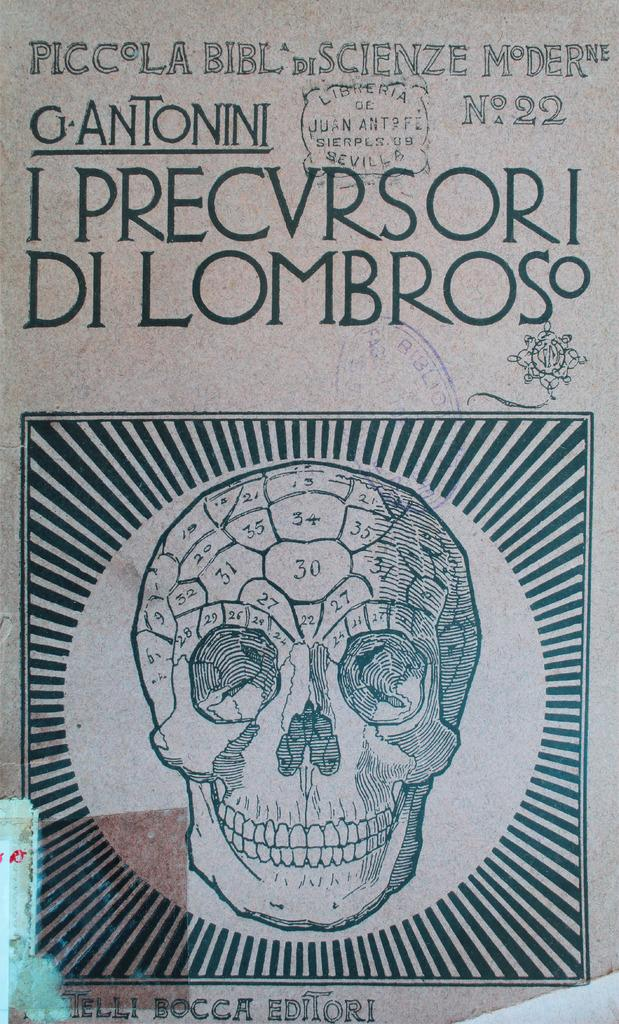<image>
Relay a brief, clear account of the picture shown. A skull with the writing I precvrsori di lombroso. 